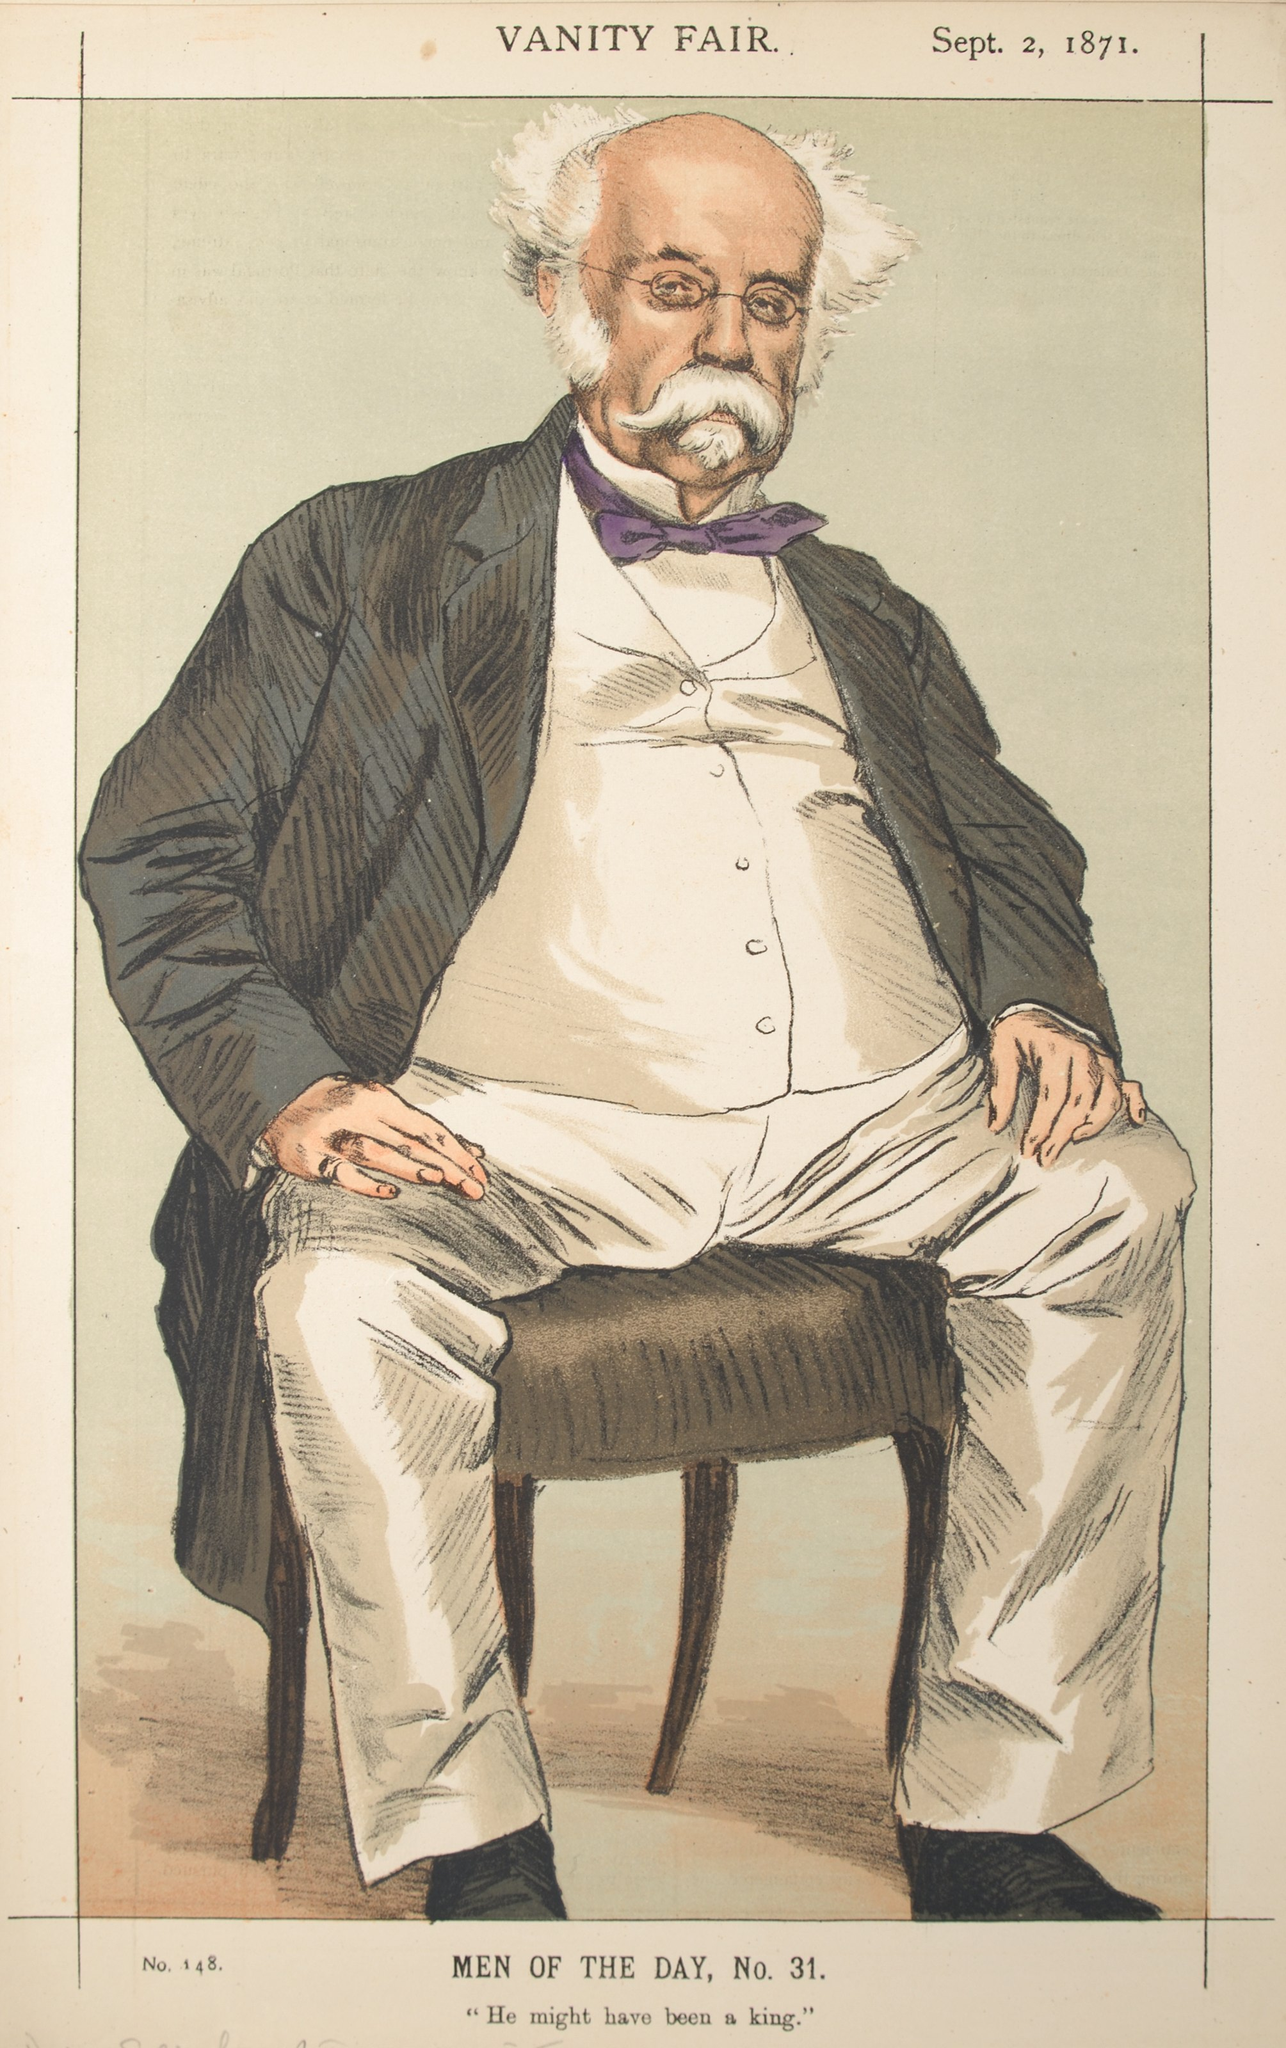Imagine if the man in the caricature could step out of the picture. What would his first words be? ‘Good heavens, have I been simply sitting here all this time? Why, you there, what year is it? Ah, splendid! Now, where might a fellow procure a fine cup of tea in this modern age?’ Describe a realistic scenario in which he actually does step out of the image and interacts in today's world. As the man in the caricature, Mr. Harold Thistlewaite, steps out of the frame and into the bustling, modern city of today, he is initially bewildered by his surroundings. Streets are filled with noisy automobiles zooming past and people engrossed in their small, handheld devices. Despite the chaotic environment, Mr. Thistlewaite maintains his composure, his polished demeanor marking him a gentleman of another era.

His first encounter is with a young tech-savvy professional named Clara, who is fascinated by his old-world charm and attire. Clara helps him navigate the technological wonders of the 21st century, explaining the workings of smartphones, internet, and social media. They sit in a cozy corner café where Harold, true to his refined taste, orders a traditional cup of Earl Grey tea.

During their conversation, he shares anecdotes from his time, recounting tales of debates in the grand halls of Parliament and soirées at the aristocratic manors. Clara listens, captivated by his eloquence and the richness of history he embodies. They forge an unlikely friendship, bridging centuries and exchanging ideas. As Harold adapts to this new world, he brings a touch of grace and wisdom from the past, highlighting the enduring values of courtesy, intellect, and curiosity. Describe a short scenario where he steps out of the image and interacts with a modern individual. Stepping out of the image, Mr. Thistlewaite, bewildered yet curious, approaches a young man fiddling with an electric scooter. 'Excuse me, young chap, might you enlighten me about this peculiar contraption?' The young man, slightly amused but intrigued, responds, 'Sure thing, sir. It's an electric scooter, pretty common these days!' They share a brief, enlightening exchange, Mr. Thistlewaite enthralled by the innovation, while the young man marvels at meeting someone out of history. 